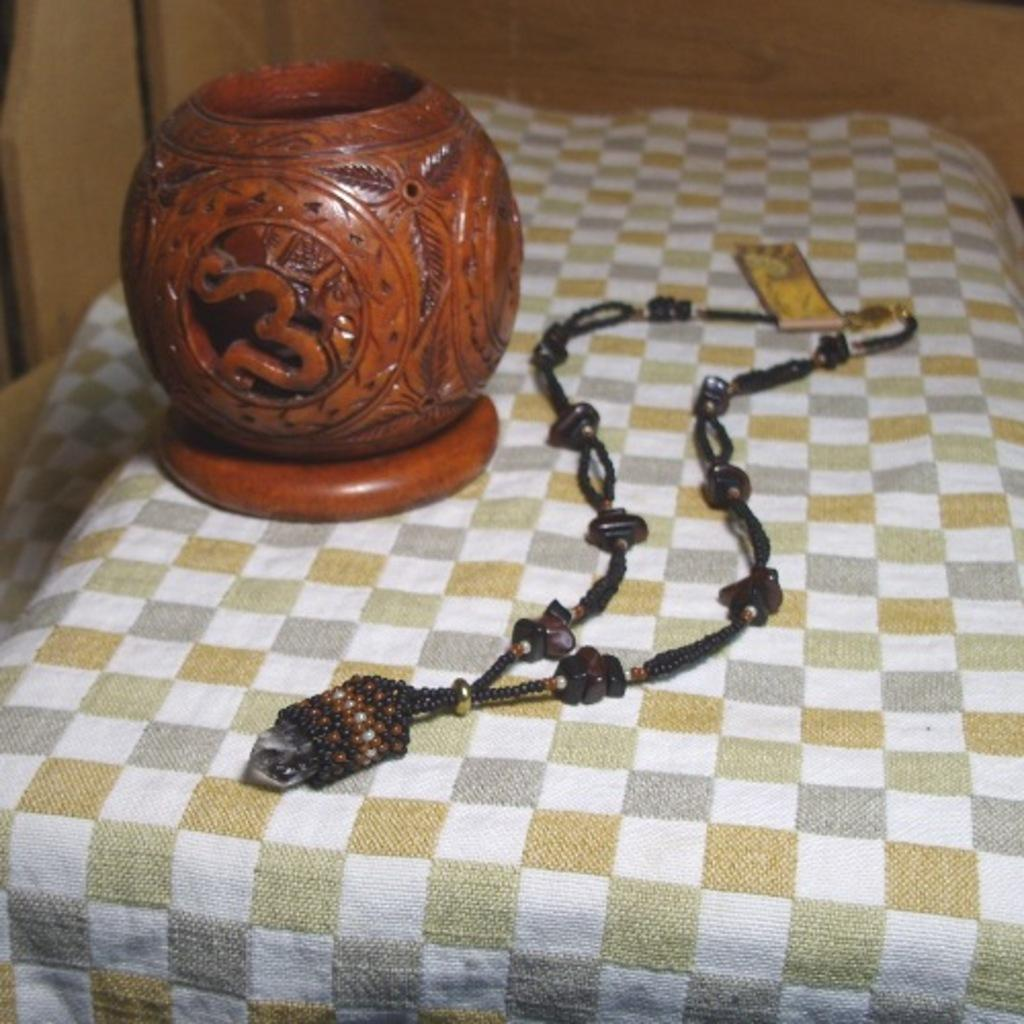What type of material is the wooden object made of in the image? The wooden object in the image is made of wood. What other item can be seen in the image besides the wooden object? There is a jewelry piece in the image. Where is the jewelry piece located in the image? The jewelry piece is on a surface in the image. Can you tell me how many boats are docked at the harbor in the image? There is no harbor or boats present in the image; it features a wooden object and a jewelry piece. What type of bean is being offered in the image? There is no bean or offering present in the image. 